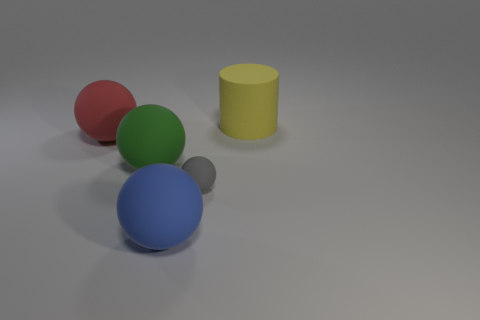Subtract all red spheres. How many spheres are left? 3 Add 2 gray objects. How many objects exist? 7 Subtract all blue spheres. How many spheres are left? 3 Subtract 1 spheres. How many spheres are left? 3 Subtract all spheres. How many objects are left? 1 Subtract all gray balls. Subtract all brown cylinders. How many balls are left? 3 Subtract all gray blocks. Subtract all gray matte balls. How many objects are left? 4 Add 4 tiny gray objects. How many tiny gray objects are left? 5 Add 3 small matte balls. How many small matte balls exist? 4 Subtract 0 green cylinders. How many objects are left? 5 